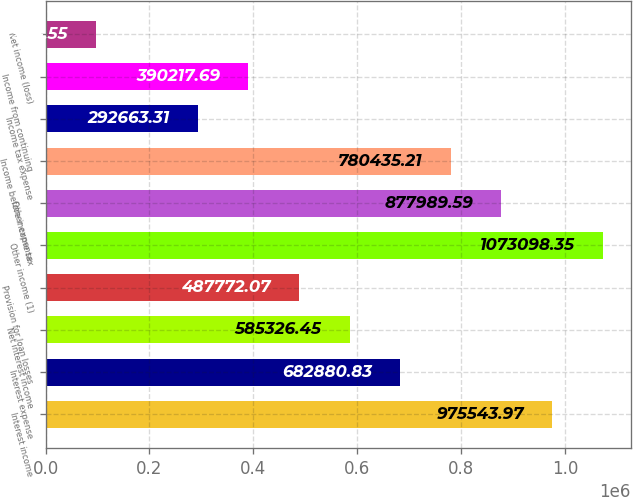Convert chart. <chart><loc_0><loc_0><loc_500><loc_500><bar_chart><fcel>Interest income<fcel>Interest expense<fcel>Net interest income<fcel>Provision for loan losses<fcel>Other income (1)<fcel>Other expense<fcel>Income before income tax<fcel>Income tax expense<fcel>Income from continuing<fcel>Net income (loss)<nl><fcel>975544<fcel>682881<fcel>585326<fcel>487772<fcel>1.0731e+06<fcel>877990<fcel>780435<fcel>292663<fcel>390218<fcel>97554.6<nl></chart> 